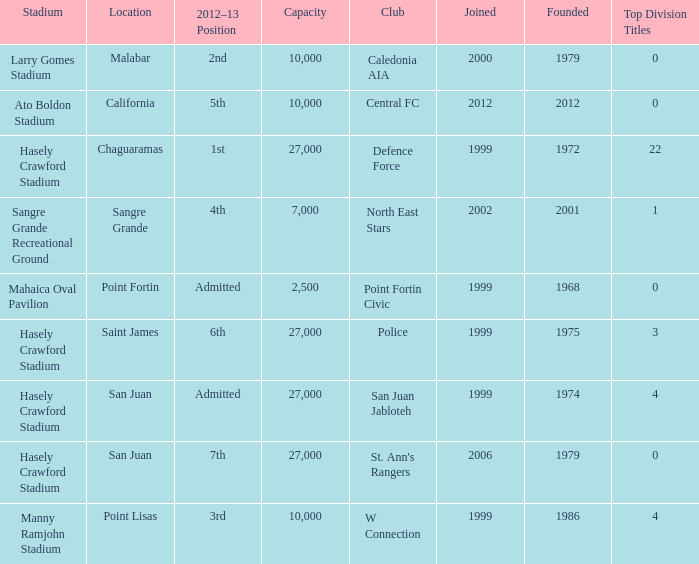What was the total number of Top Division Titles where the year founded was prior to 1975 and the location was in Chaguaramas? 22.0. 